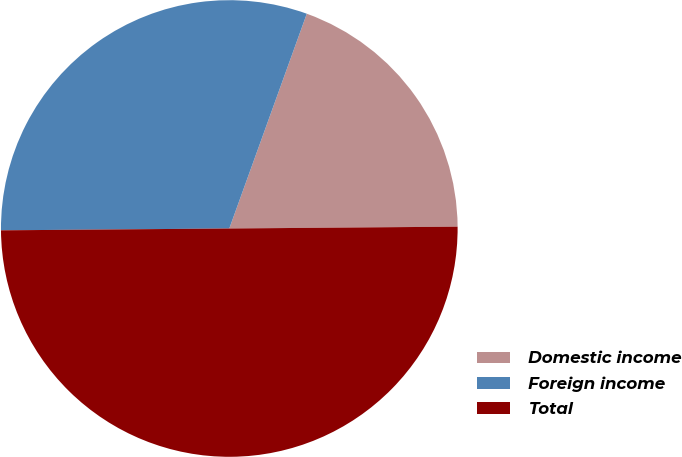Convert chart. <chart><loc_0><loc_0><loc_500><loc_500><pie_chart><fcel>Domestic income<fcel>Foreign income<fcel>Total<nl><fcel>19.36%<fcel>30.64%<fcel>50.0%<nl></chart> 